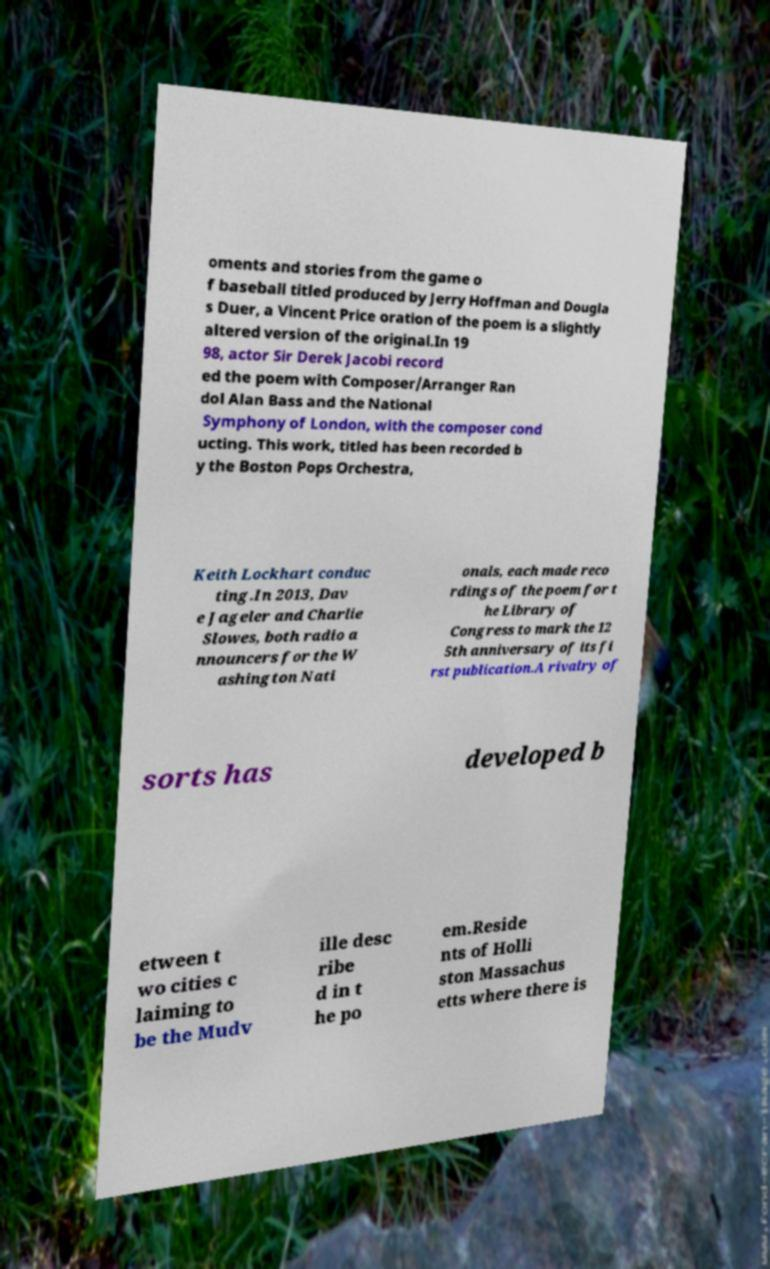Can you read and provide the text displayed in the image?This photo seems to have some interesting text. Can you extract and type it out for me? oments and stories from the game o f baseball titled produced by Jerry Hoffman and Dougla s Duer, a Vincent Price oration of the poem is a slightly altered version of the original.In 19 98, actor Sir Derek Jacobi record ed the poem with Composer/Arranger Ran dol Alan Bass and the National Symphony of London, with the composer cond ucting. This work, titled has been recorded b y the Boston Pops Orchestra, Keith Lockhart conduc ting.In 2013, Dav e Jageler and Charlie Slowes, both radio a nnouncers for the W ashington Nati onals, each made reco rdings of the poem for t he Library of Congress to mark the 12 5th anniversary of its fi rst publication.A rivalry of sorts has developed b etween t wo cities c laiming to be the Mudv ille desc ribe d in t he po em.Reside nts of Holli ston Massachus etts where there is 